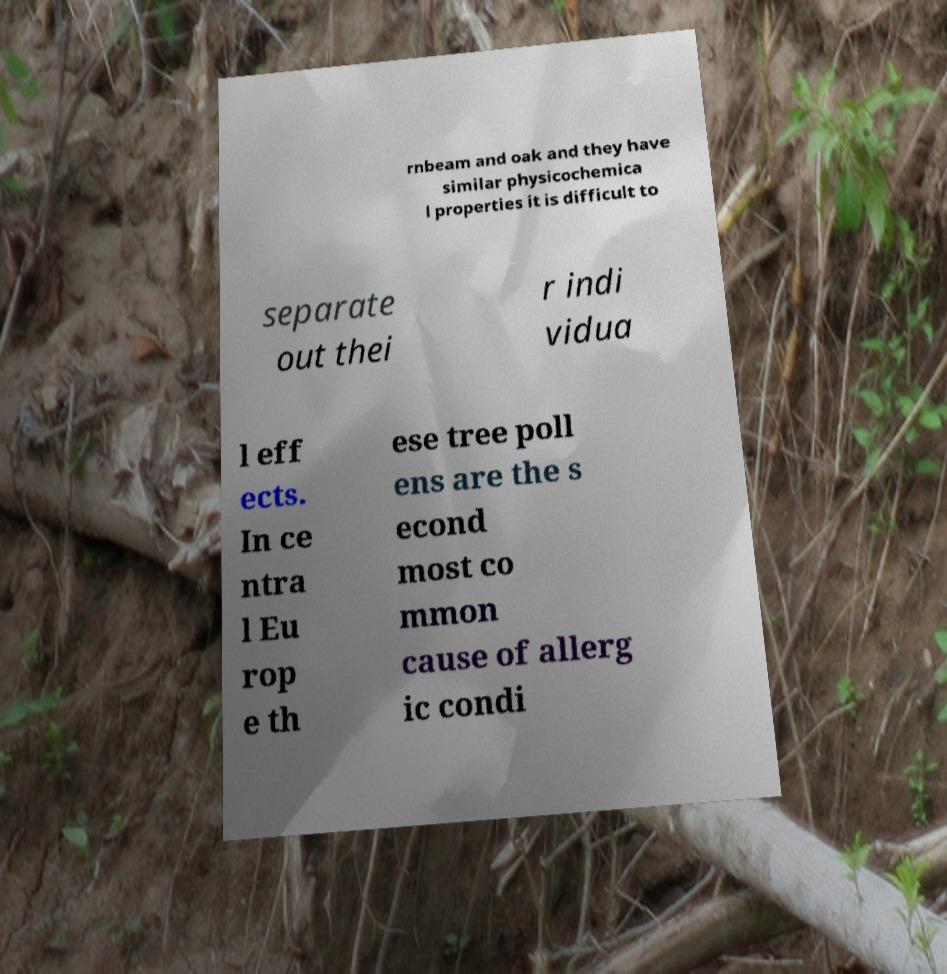Please identify and transcribe the text found in this image. rnbeam and oak and they have similar physicochemica l properties it is difficult to separate out thei r indi vidua l eff ects. In ce ntra l Eu rop e th ese tree poll ens are the s econd most co mmon cause of allerg ic condi 